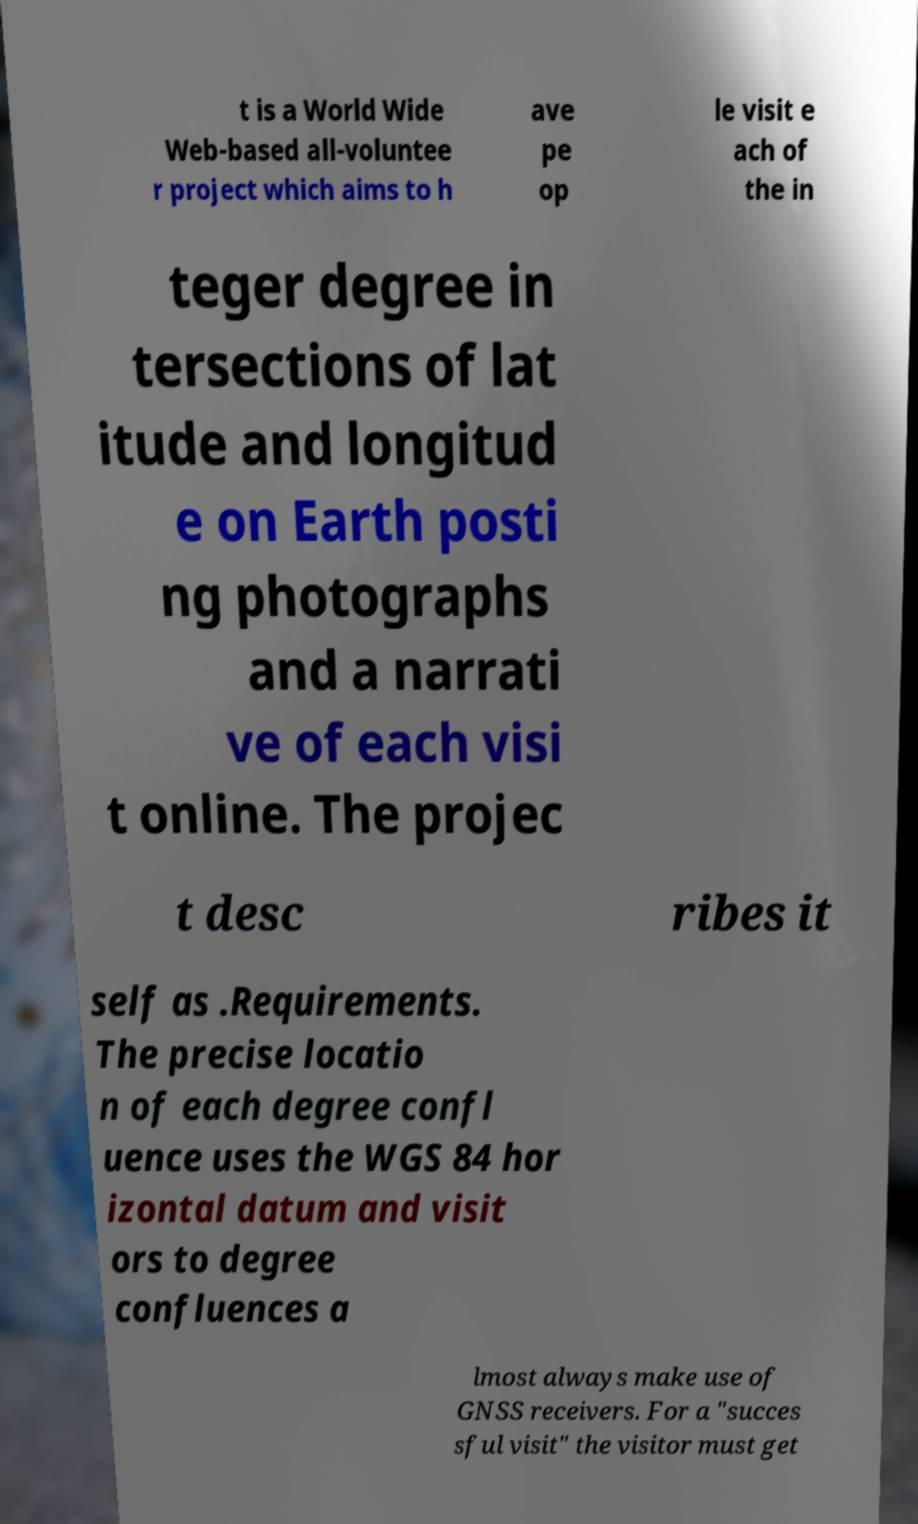What messages or text are displayed in this image? I need them in a readable, typed format. t is a World Wide Web-based all-voluntee r project which aims to h ave pe op le visit e ach of the in teger degree in tersections of lat itude and longitud e on Earth posti ng photographs and a narrati ve of each visi t online. The projec t desc ribes it self as .Requirements. The precise locatio n of each degree confl uence uses the WGS 84 hor izontal datum and visit ors to degree confluences a lmost always make use of GNSS receivers. For a "succes sful visit" the visitor must get 